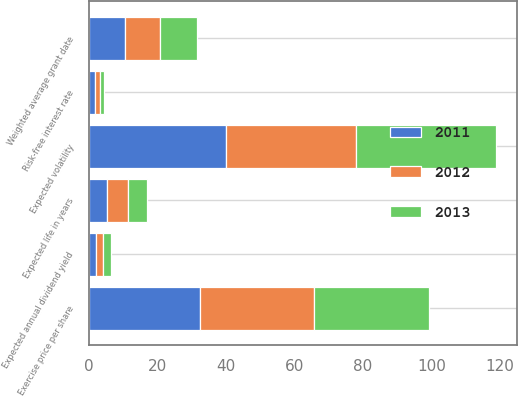Convert chart. <chart><loc_0><loc_0><loc_500><loc_500><stacked_bar_chart><ecel><fcel>Exercise price per share<fcel>Expected annual dividend yield<fcel>Expected life in years<fcel>Expected volatility<fcel>Risk-free interest rate<fcel>Weighted average grant date<nl><fcel>2012<fcel>33.54<fcel>2.1<fcel>6.1<fcel>38<fcel>1.6<fcel>10.25<nl><fcel>2013<fcel>33.52<fcel>2.2<fcel>5.5<fcel>41<fcel>1.2<fcel>10.86<nl><fcel>2011<fcel>32.3<fcel>2.1<fcel>5.3<fcel>40<fcel>1.7<fcel>10.44<nl></chart> 